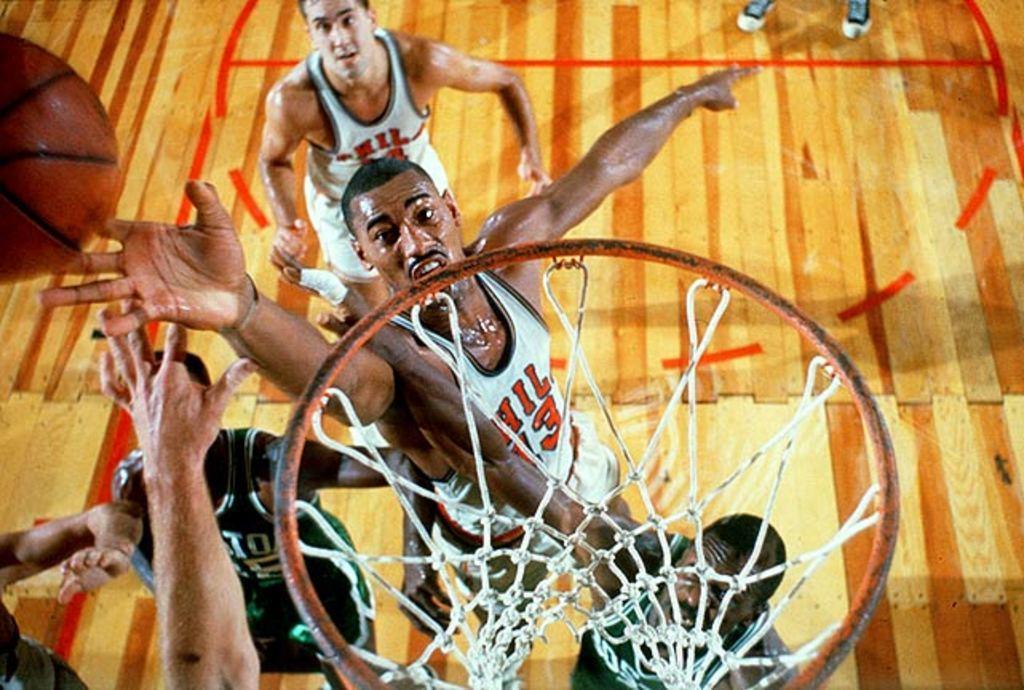Can you describe this image briefly? In this image we can see men standing on the wooden floor, ball and a basketball basket. 